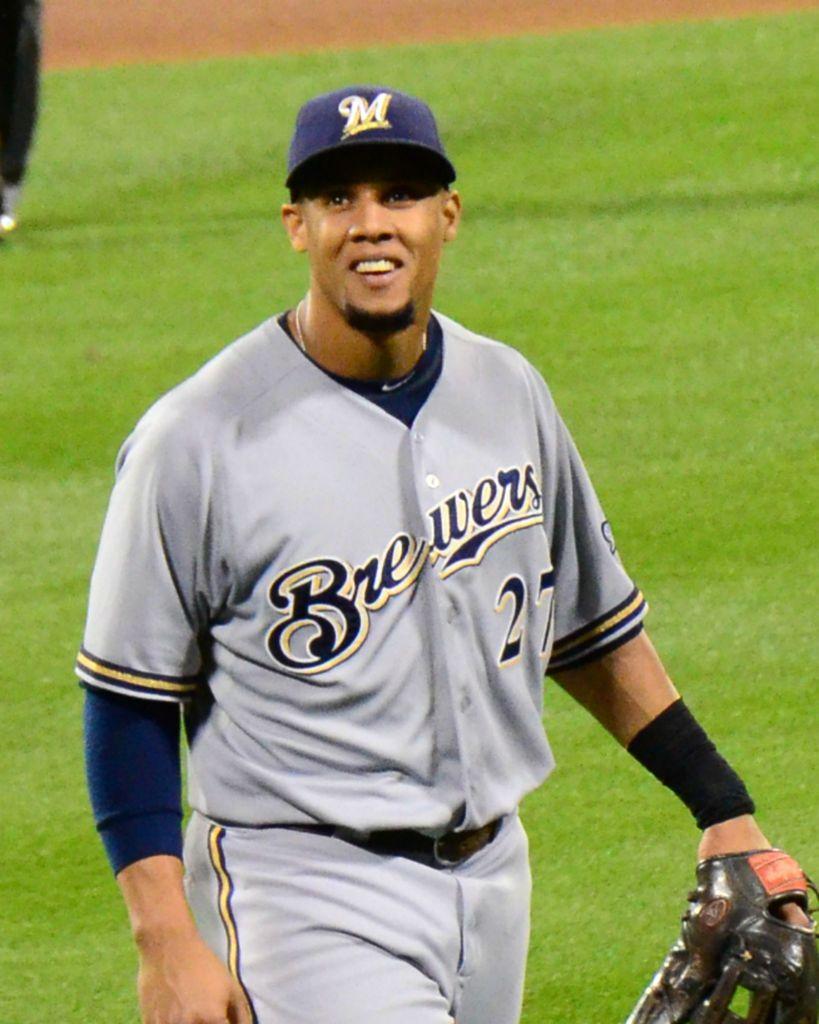What team is the player playing for ?
Your answer should be compact. Brewers. What is the name of the player's team?
Provide a short and direct response. Brewers. 